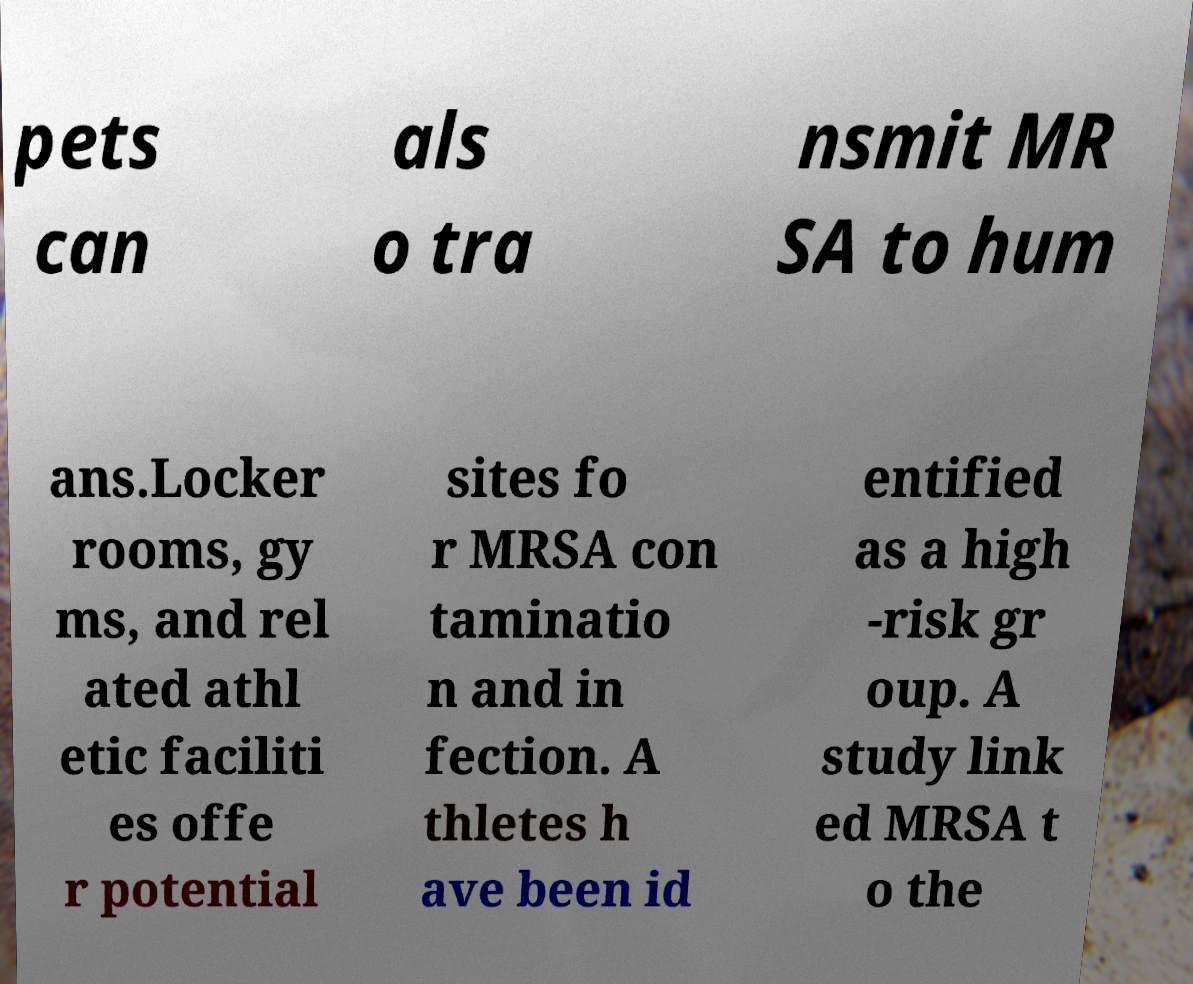Please identify and transcribe the text found in this image. pets can als o tra nsmit MR SA to hum ans.Locker rooms, gy ms, and rel ated athl etic faciliti es offe r potential sites fo r MRSA con taminatio n and in fection. A thletes h ave been id entified as a high -risk gr oup. A study link ed MRSA t o the 